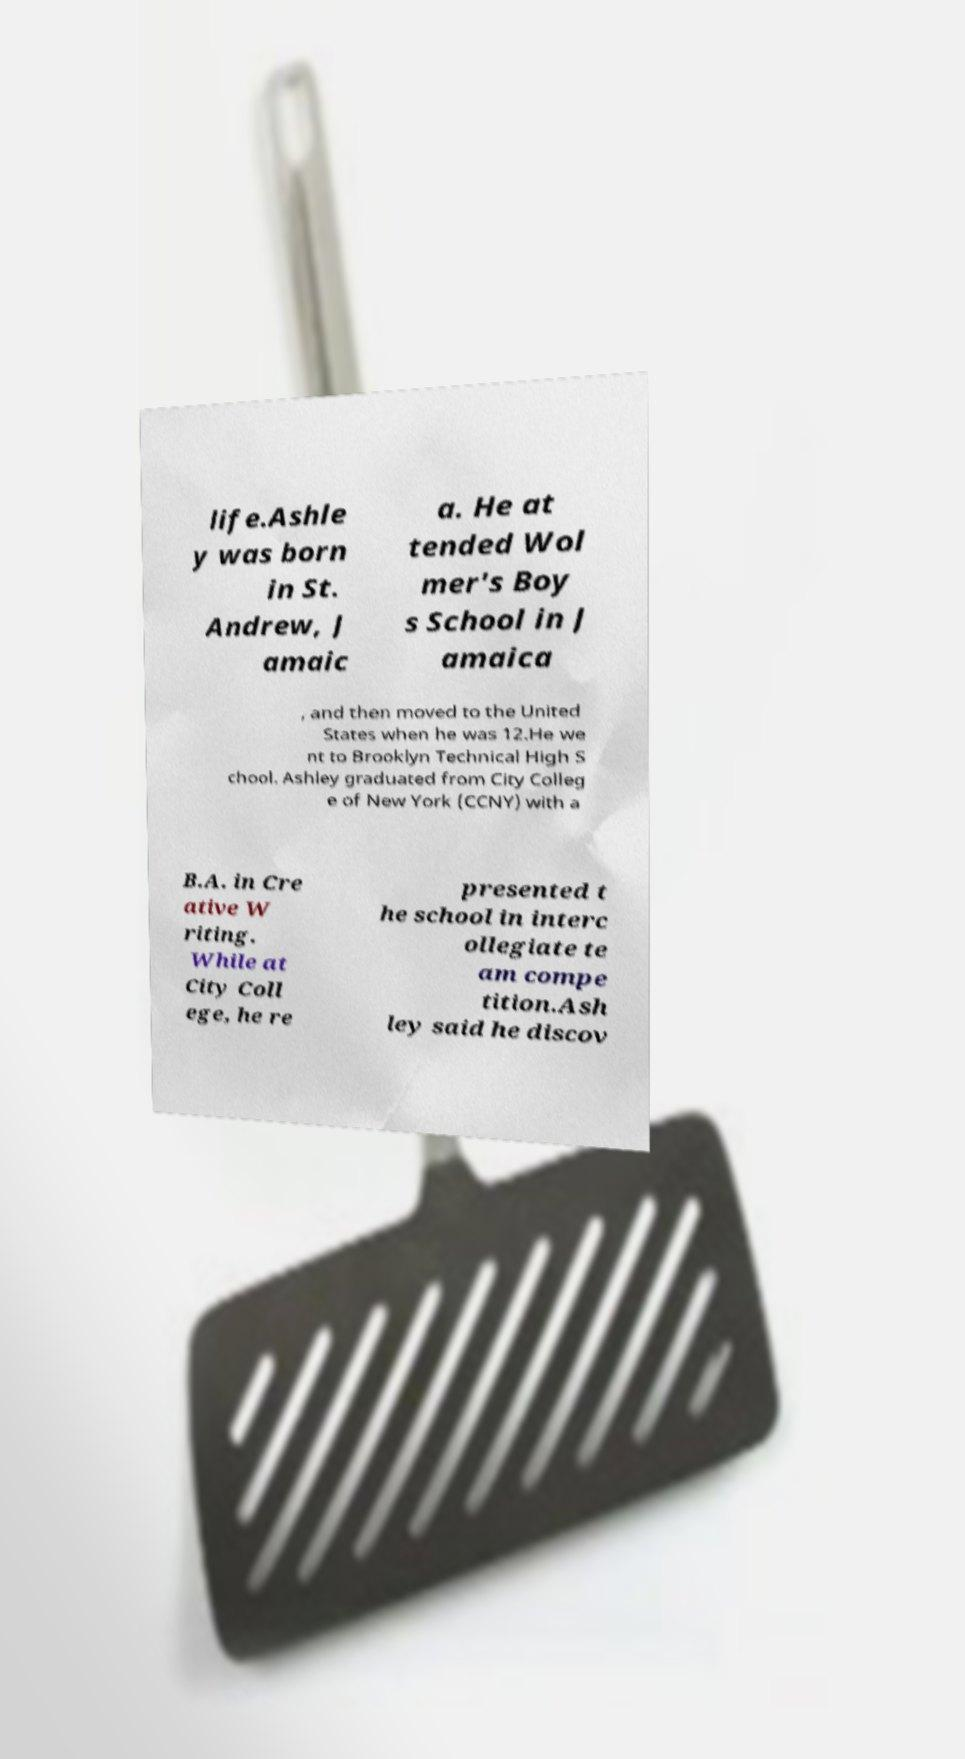Please identify and transcribe the text found in this image. life.Ashle y was born in St. Andrew, J amaic a. He at tended Wol mer's Boy s School in J amaica , and then moved to the United States when he was 12.He we nt to Brooklyn Technical High S chool. Ashley graduated from City Colleg e of New York (CCNY) with a B.A. in Cre ative W riting. While at City Coll ege, he re presented t he school in interc ollegiate te am compe tition.Ash ley said he discov 